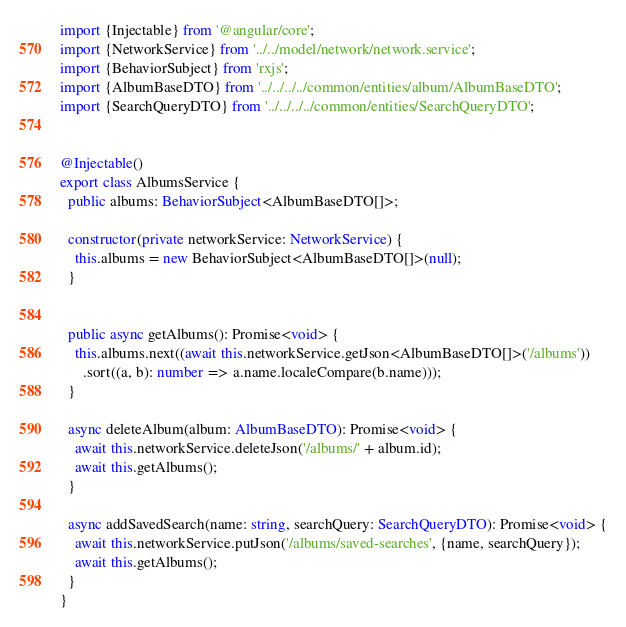Convert code to text. <code><loc_0><loc_0><loc_500><loc_500><_TypeScript_>import {Injectable} from '@angular/core';
import {NetworkService} from '../../model/network/network.service';
import {BehaviorSubject} from 'rxjs';
import {AlbumBaseDTO} from '../../../../common/entities/album/AlbumBaseDTO';
import {SearchQueryDTO} from '../../../../common/entities/SearchQueryDTO';


@Injectable()
export class AlbumsService {
  public albums: BehaviorSubject<AlbumBaseDTO[]>;

  constructor(private networkService: NetworkService) {
    this.albums = new BehaviorSubject<AlbumBaseDTO[]>(null);
  }


  public async getAlbums(): Promise<void> {
    this.albums.next((await this.networkService.getJson<AlbumBaseDTO[]>('/albums'))
      .sort((a, b): number => a.name.localeCompare(b.name)));
  }

  async deleteAlbum(album: AlbumBaseDTO): Promise<void> {
    await this.networkService.deleteJson('/albums/' + album.id);
    await this.getAlbums();
  }

  async addSavedSearch(name: string, searchQuery: SearchQueryDTO): Promise<void> {
    await this.networkService.putJson('/albums/saved-searches', {name, searchQuery});
    await this.getAlbums();
  }
}
</code> 